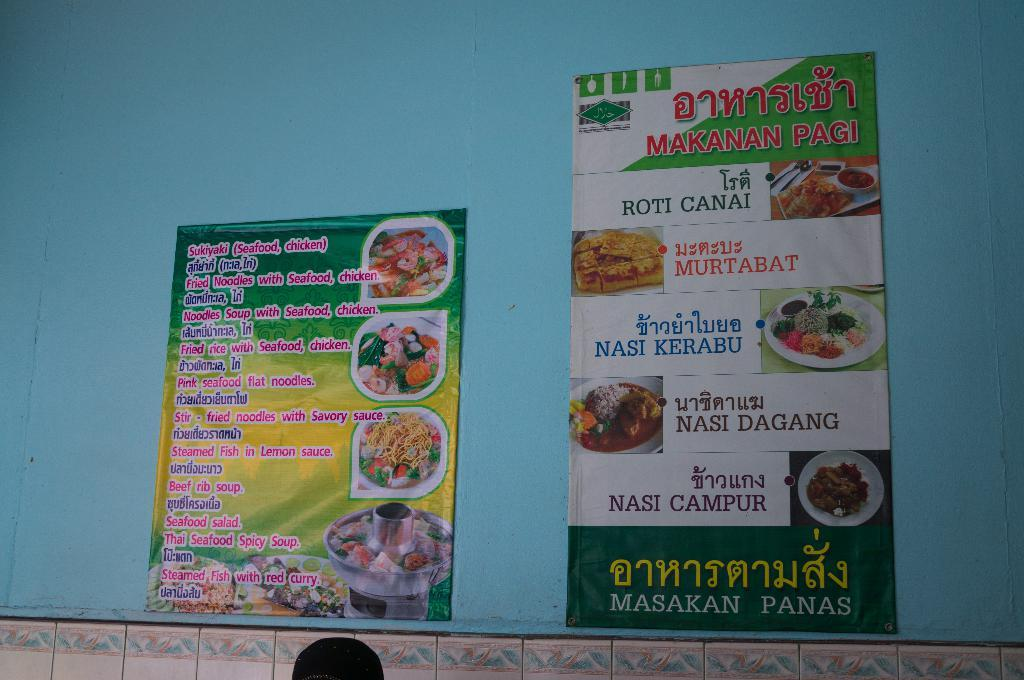What is hanging on the wall in the image? There are two banners on a wall in the image. What can be seen on the banners? The banners have text and pictures of food on them. What type of surface is visible at the bottom of the image? There are tiles at the bottom of the image. What type of engine is depicted on the banners? There is no engine depicted on the banners; they feature text and pictures of food. How many keys are visible on the banners? There are no keys visible on the banners; they only have text and pictures of food. 